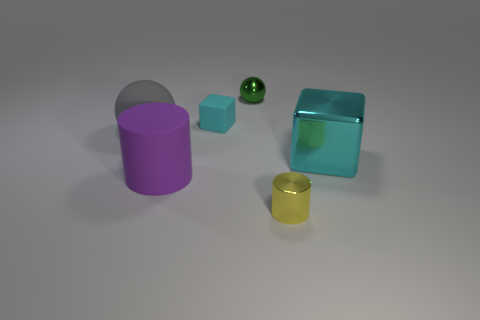Is the size of the green object the same as the yellow metal cylinder?
Your answer should be very brief. Yes. There is a tiny thing that is to the right of the tiny cyan thing and in front of the small green metallic ball; what color is it?
Offer a very short reply. Yellow. The cyan rubber object has what size?
Make the answer very short. Small. There is a cube in front of the gray rubber thing; is it the same color as the metal cylinder?
Offer a very short reply. No. Are there more large purple objects that are right of the tiny ball than large cyan blocks in front of the big gray matte ball?
Offer a very short reply. No. Are there more red cylinders than tiny cyan matte objects?
Provide a succinct answer. No. There is a metallic thing that is left of the big cyan shiny cube and behind the tiny yellow cylinder; what size is it?
Provide a short and direct response. Small. The purple matte thing is what shape?
Offer a very short reply. Cylinder. Is there any other thing that has the same size as the purple matte cylinder?
Ensure brevity in your answer.  Yes. Is the number of big cyan metallic blocks that are right of the big rubber sphere greater than the number of large cyan metal things?
Offer a terse response. No. 